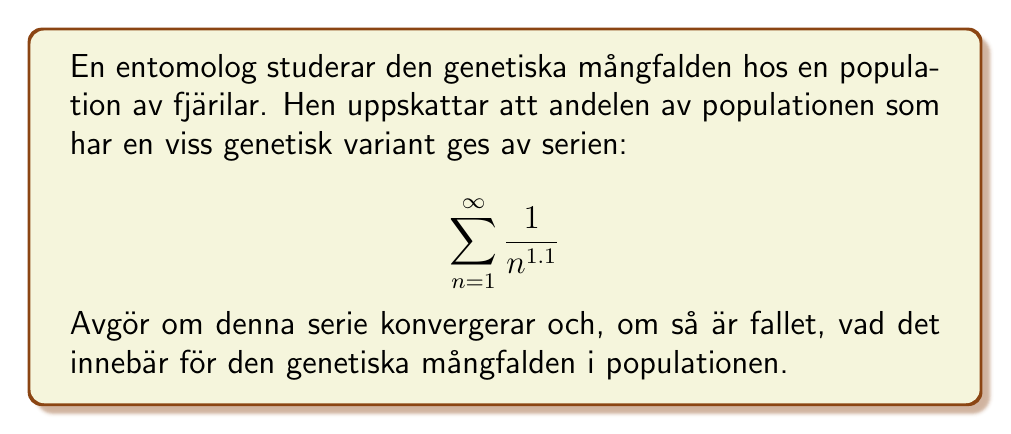Can you solve this math problem? För att avgöra om serien konvergerar, kan vi använda p-serietestet.

1) En p-serie har formen $\sum_{n=1}^{\infty} \frac{1}{n^p}$, där p är en konstant.

2) I detta fall är $p = 1.1$

3) Enligt p-serietestet:
   - Om $p > 1$, konvergerar serien
   - Om $p \leq 1$, divergerar serien

4) Eftersom $1.1 > 1$, konvergerar serien.

5) För att förstå vad detta innebär biologiskt:
   - Konvergens betyder att summan av alla termer närmar sig ett ändligt värde.
   - I detta sammanhang representerar varje term i serien andelen av populationen med en specifik genetisk variant.
   - Att serien konvergerar innebär att den totala andelen av populationen som har denna genetiska variant är begränsad och inte överskrider 100%.

6) Det exakta värdet som serien konvergerar till kan beräknas numeriskt, men det viktiga här är att det är ett ändligt värde mindre än 1 (eller 100%).

Detta resultat indikerar att den genetiska varianten är närvarande i populationen men inte dominant, vilket bidrar till genetisk mångfald utan att helt ta över populationens genpool.
Answer: Serien konvergerar. Biologiskt sett innebär detta att den specifika genetiska varianten förekommer i en begränsad men stabil andel av fjärilspopulationen, vilket bidrar till genetisk mångfald utan att dominera genpoolen. 